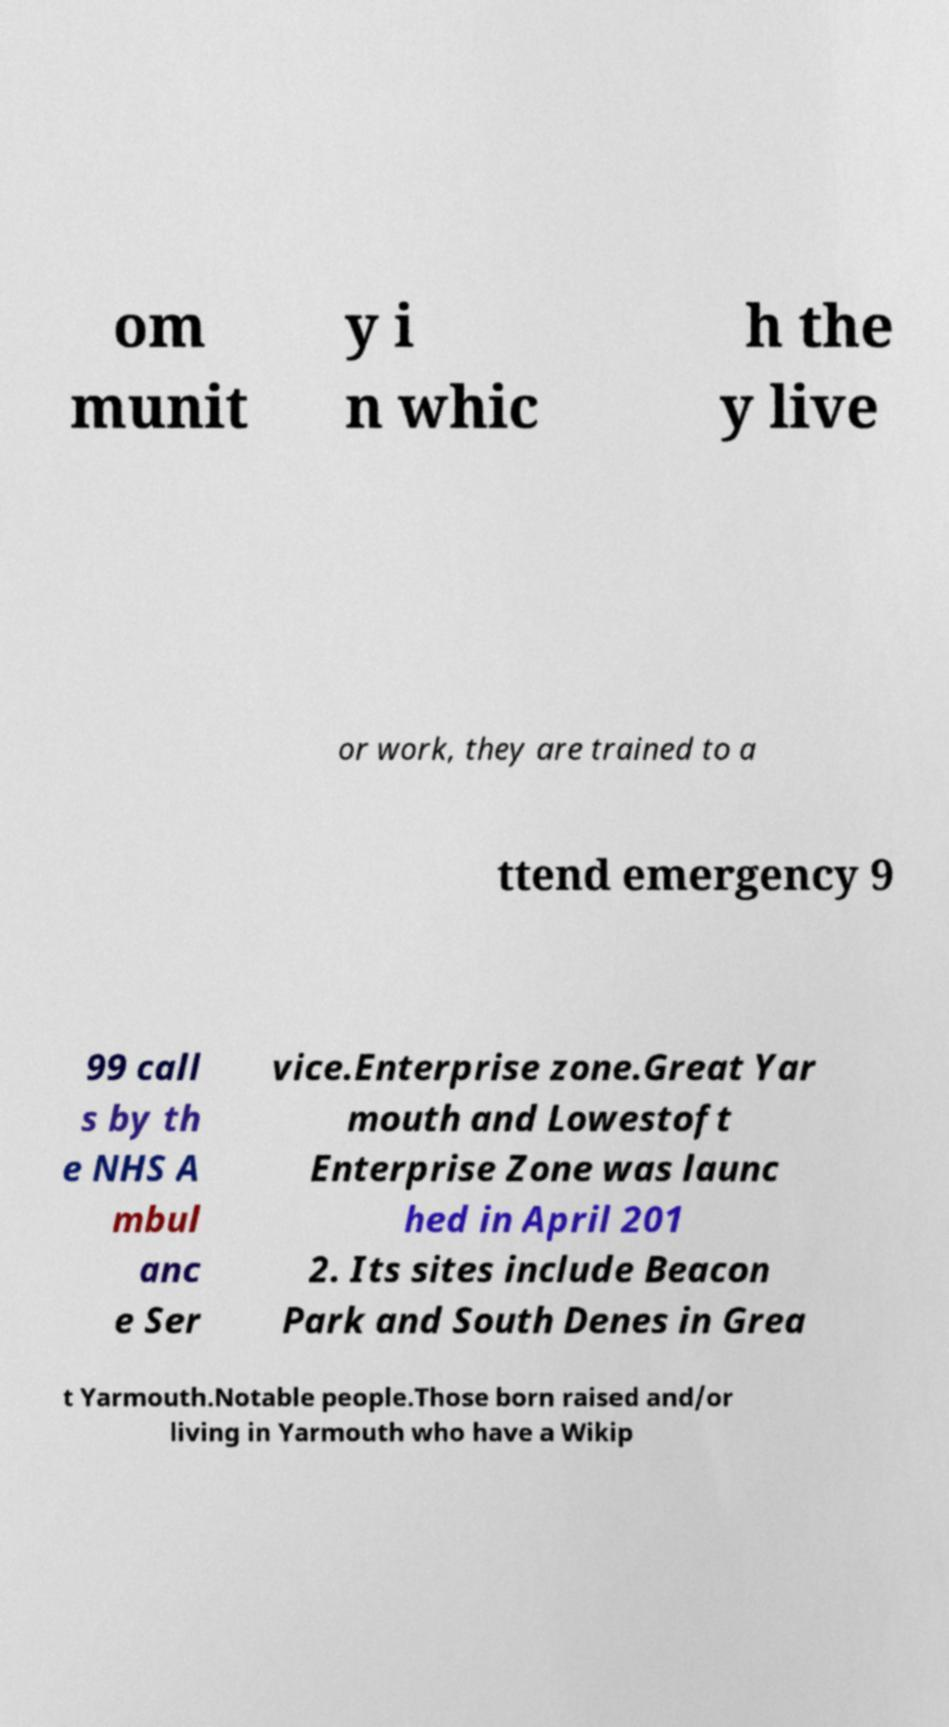For documentation purposes, I need the text within this image transcribed. Could you provide that? om munit y i n whic h the y live or work, they are trained to a ttend emergency 9 99 call s by th e NHS A mbul anc e Ser vice.Enterprise zone.Great Yar mouth and Lowestoft Enterprise Zone was launc hed in April 201 2. Its sites include Beacon Park and South Denes in Grea t Yarmouth.Notable people.Those born raised and/or living in Yarmouth who have a Wikip 